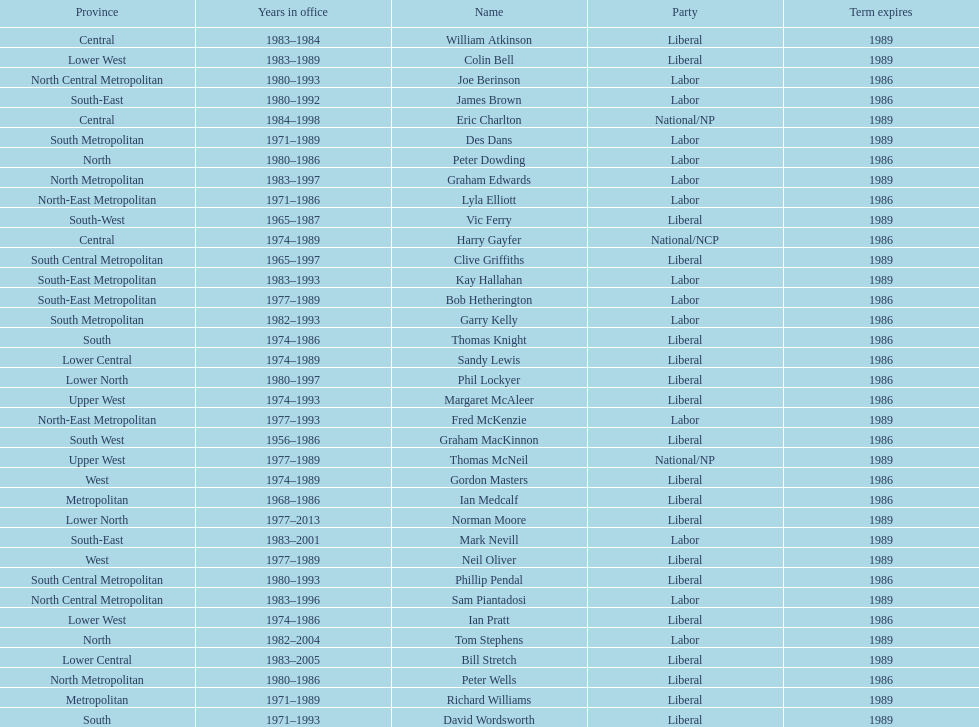Hame the last member listed whose last name begins with "p". Ian Pratt. 